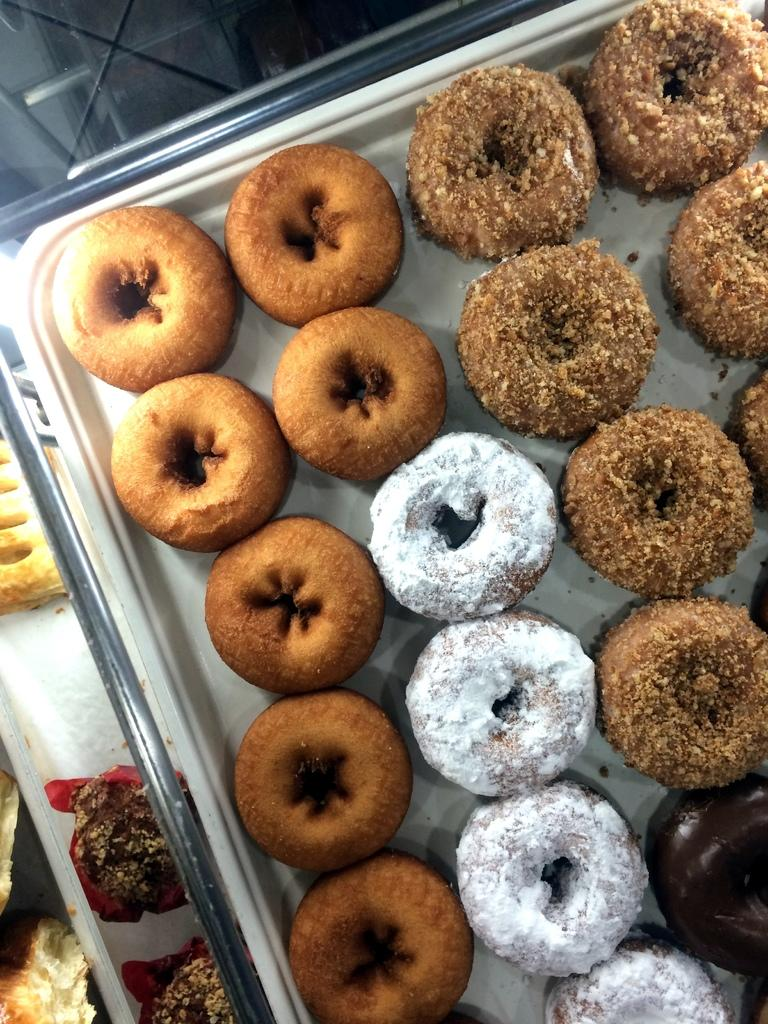What types of food are visible in the image? There are different types of donuts in the image. How are the donuts organized in the image? The donuts are arranged in trays. What reason did the donuts have for participating in a battle in the image? There is no battle or reason for the donuts to participate in one in the image; they are simply arranged in trays. Can you see any donuts with ears in the image? There are no donuts with ears in the image, as donuts do not have ears. 